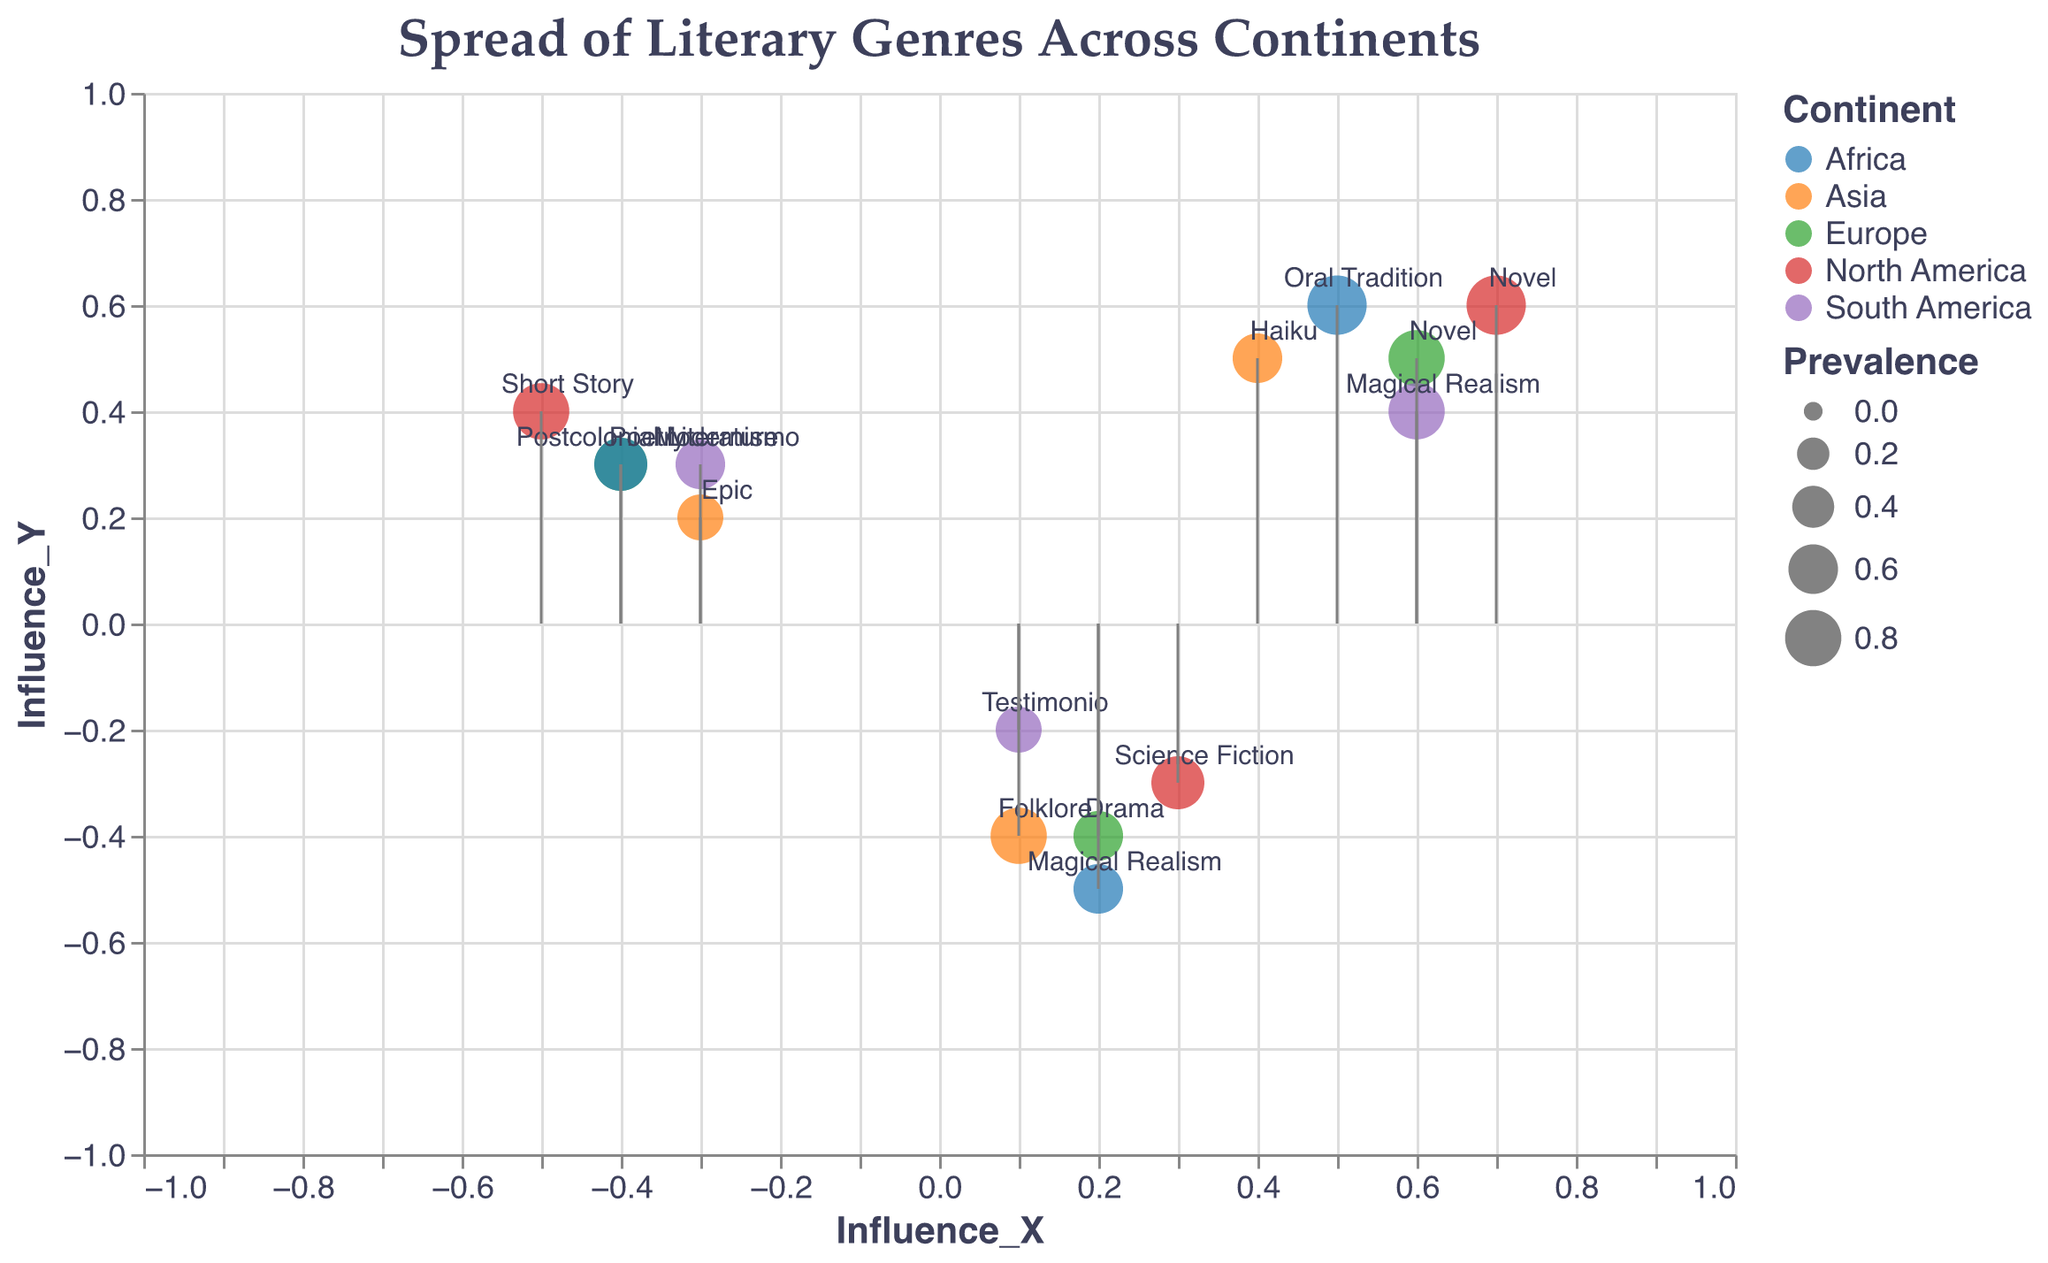Which continent has the genre with the highest prevalence? The genre "Novel" in North America has the highest prevalence, with a value of 0.9. This can be observed by looking at the size of the points in the plot and identifying the largest one.
Answer: North America How is the influence of "Poetry" in Europe depicted in the plot? The influence of "Poetry" in Europe is indicated by a vector pointing left (negative X) and slightly upward (positive Y), with coordinates (-0.4, 0.3). You can see this on the plot where "Poetry" in Europe has vectors starting from its point and extending in those directions.
Answer: Leftward and upward What is the direction and length of the vector for "Magical Realism" in South America? The vector for "Magical Realism" in South America points right (positive X) and upward (positive Y), with coordinates (0.6, 0.4). The length of the vector can be derived using the Euclidean distance formula sqrt((0.6)^2 + (0.4)^2) = sqrt(0.52) ≈ 0.72.
Answer: Right and upward, length ≈ 0.72 Compare the prevalence of "Haiku" in Asia to "Oral Tradition" in Africa. Which is higher? By examining the sizes of the points for "Haiku" in Asia and "Oral Tradition" in Africa, we see that the size of the point for "Oral Tradition" is larger than "Haiku". The prevalence values are 0.9 (Oral Tradition) and 0.6 (Haiku), respectively. Therefore, "Oral Tradition" in Africa has a higher prevalence.
Answer: "Oral Tradition" in Africa Identify the genre with the least prevalence in South America and its influence direction. The genre "Testimonio" in South America has the least prevalence with a value of 0.5. Its influence vector points slightly right (positive X) and downward (negative Y) with coordinates (0.1, -0.2).
Answer: "Testimonio", right and downward Which genres in Europe have negative influence in the Y-direction? In Europe, the genres "Drama" and "Poetry" have negative Y-direction influences. "Drama" has (0.2, -0.4), and "Poetry" has (-0.4, 0.3) where we see a downward component in the plot for "Drama".
Answer: "Drama" What is the influence direction difference between "Science Fiction" in North America and "Epic" in Asia? "Science Fiction" in North America has influence coordinates (0.3, -0.3), while "Epic" in Asia has coordinates (-0.3, 0.2). The difference in X is 0.3 - (-0.3) = 0.6, and the difference in Y is -0.3 - 0.2 = -0.5.
Answer: X difference: 0.6, Y difference: -0.5 